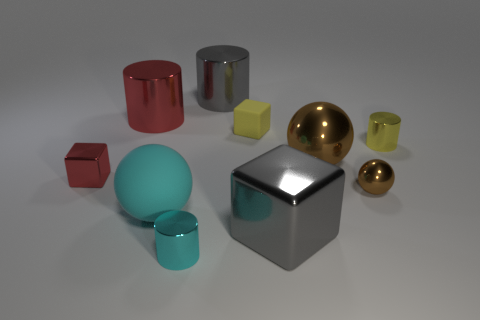What number of things are large objects to the right of the cyan sphere or large brown objects?
Offer a terse response. 3. Are there the same number of small red shiny things that are in front of the tiny shiny ball and gray cylinders that are behind the big red metallic object?
Provide a succinct answer. No. How many other things are the same shape as the small brown thing?
Provide a succinct answer. 2. Do the matte block right of the small cyan object and the thing in front of the large gray cube have the same size?
Make the answer very short. Yes. What number of blocks are small brown shiny objects or large red metal things?
Keep it short and to the point. 0. How many metallic things are cyan cylinders or cyan spheres?
Make the answer very short. 1. There is a yellow metallic object that is the same shape as the small cyan metallic thing; what size is it?
Make the answer very short. Small. Is there any other thing that has the same size as the gray cube?
Make the answer very short. Yes. There is a red metal block; is it the same size as the gray metal object that is behind the large matte object?
Your response must be concise. No. What shape is the gray metallic object behind the small brown ball?
Your answer should be very brief. Cylinder. 